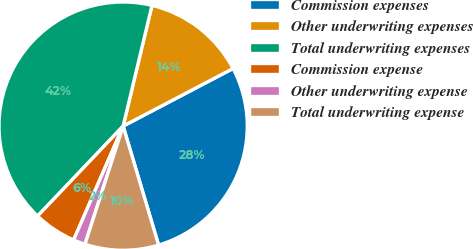<chart> <loc_0><loc_0><loc_500><loc_500><pie_chart><fcel>Commission expenses<fcel>Other underwriting expenses<fcel>Total underwriting expenses<fcel>Commission expense<fcel>Other underwriting expense<fcel>Total underwriting expense<nl><fcel>28.07%<fcel>13.58%<fcel>41.63%<fcel>5.57%<fcel>1.56%<fcel>9.58%<nl></chart> 